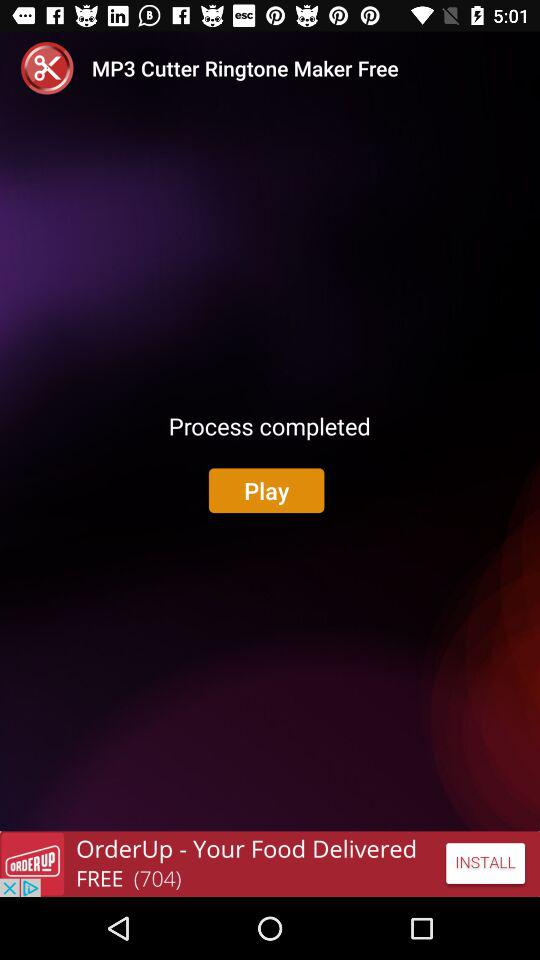What is the name of the application? The name of the application is "MP3 Cutter Ringtone Maker Free". 